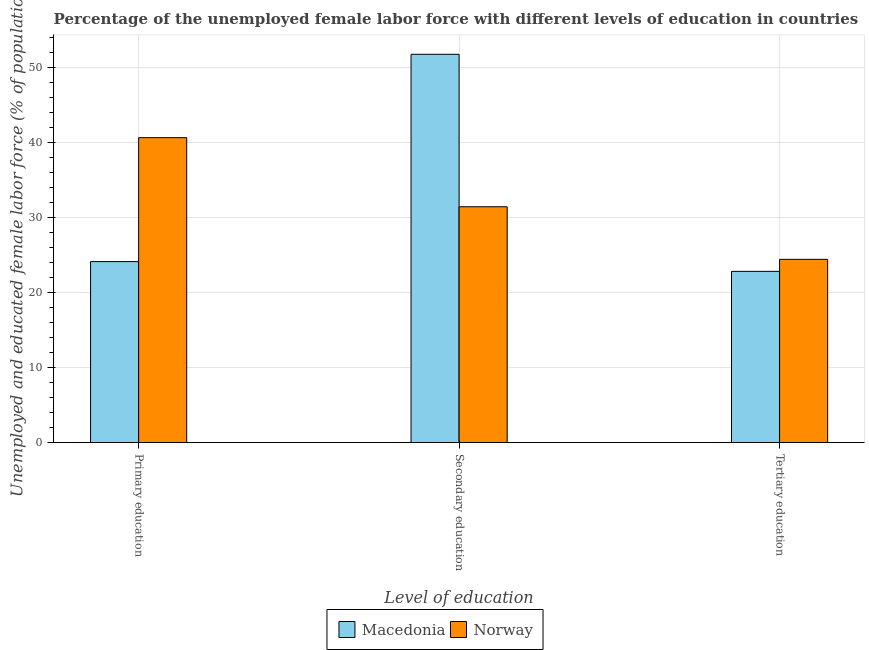How many groups of bars are there?
Your answer should be very brief. 3. Are the number of bars per tick equal to the number of legend labels?
Ensure brevity in your answer.  Yes. How many bars are there on the 3rd tick from the left?
Provide a succinct answer. 2. How many bars are there on the 2nd tick from the right?
Offer a very short reply. 2. What is the label of the 3rd group of bars from the left?
Keep it short and to the point. Tertiary education. What is the percentage of female labor force who received secondary education in Norway?
Your answer should be very brief. 31.4. Across all countries, what is the maximum percentage of female labor force who received primary education?
Your response must be concise. 40.6. Across all countries, what is the minimum percentage of female labor force who received tertiary education?
Keep it short and to the point. 22.8. In which country was the percentage of female labor force who received secondary education minimum?
Your answer should be compact. Norway. What is the total percentage of female labor force who received secondary education in the graph?
Offer a terse response. 83.1. What is the difference between the percentage of female labor force who received tertiary education in Norway and that in Macedonia?
Your answer should be very brief. 1.6. What is the difference between the percentage of female labor force who received tertiary education in Norway and the percentage of female labor force who received primary education in Macedonia?
Offer a terse response. 0.3. What is the average percentage of female labor force who received secondary education per country?
Keep it short and to the point. 41.55. What is the difference between the percentage of female labor force who received primary education and percentage of female labor force who received tertiary education in Norway?
Ensure brevity in your answer.  16.2. In how many countries, is the percentage of female labor force who received tertiary education greater than 24 %?
Provide a succinct answer. 1. What is the ratio of the percentage of female labor force who received tertiary education in Norway to that in Macedonia?
Offer a terse response. 1.07. Is the percentage of female labor force who received primary education in Norway less than that in Macedonia?
Your answer should be very brief. No. Is the difference between the percentage of female labor force who received primary education in Macedonia and Norway greater than the difference between the percentage of female labor force who received secondary education in Macedonia and Norway?
Your answer should be compact. No. What is the difference between the highest and the second highest percentage of female labor force who received tertiary education?
Your answer should be compact. 1.6. What is the difference between the highest and the lowest percentage of female labor force who received primary education?
Your answer should be compact. 16.5. In how many countries, is the percentage of female labor force who received secondary education greater than the average percentage of female labor force who received secondary education taken over all countries?
Your answer should be compact. 1. Is the sum of the percentage of female labor force who received primary education in Norway and Macedonia greater than the maximum percentage of female labor force who received secondary education across all countries?
Offer a terse response. Yes. What does the 1st bar from the right in Secondary education represents?
Give a very brief answer. Norway. How many bars are there?
Offer a very short reply. 6. Are all the bars in the graph horizontal?
Provide a short and direct response. No. How many countries are there in the graph?
Your answer should be very brief. 2. What is the difference between two consecutive major ticks on the Y-axis?
Offer a very short reply. 10. Are the values on the major ticks of Y-axis written in scientific E-notation?
Your answer should be very brief. No. How are the legend labels stacked?
Offer a terse response. Horizontal. What is the title of the graph?
Make the answer very short. Percentage of the unemployed female labor force with different levels of education in countries. Does "Middle East & North Africa (all income levels)" appear as one of the legend labels in the graph?
Offer a very short reply. No. What is the label or title of the X-axis?
Provide a succinct answer. Level of education. What is the label or title of the Y-axis?
Provide a succinct answer. Unemployed and educated female labor force (% of population). What is the Unemployed and educated female labor force (% of population) in Macedonia in Primary education?
Ensure brevity in your answer.  24.1. What is the Unemployed and educated female labor force (% of population) of Norway in Primary education?
Keep it short and to the point. 40.6. What is the Unemployed and educated female labor force (% of population) of Macedonia in Secondary education?
Offer a very short reply. 51.7. What is the Unemployed and educated female labor force (% of population) in Norway in Secondary education?
Your answer should be compact. 31.4. What is the Unemployed and educated female labor force (% of population) of Macedonia in Tertiary education?
Ensure brevity in your answer.  22.8. What is the Unemployed and educated female labor force (% of population) of Norway in Tertiary education?
Your response must be concise. 24.4. Across all Level of education, what is the maximum Unemployed and educated female labor force (% of population) in Macedonia?
Ensure brevity in your answer.  51.7. Across all Level of education, what is the maximum Unemployed and educated female labor force (% of population) in Norway?
Give a very brief answer. 40.6. Across all Level of education, what is the minimum Unemployed and educated female labor force (% of population) in Macedonia?
Make the answer very short. 22.8. Across all Level of education, what is the minimum Unemployed and educated female labor force (% of population) of Norway?
Make the answer very short. 24.4. What is the total Unemployed and educated female labor force (% of population) in Macedonia in the graph?
Keep it short and to the point. 98.6. What is the total Unemployed and educated female labor force (% of population) in Norway in the graph?
Give a very brief answer. 96.4. What is the difference between the Unemployed and educated female labor force (% of population) in Macedonia in Primary education and that in Secondary education?
Your answer should be very brief. -27.6. What is the difference between the Unemployed and educated female labor force (% of population) in Norway in Primary education and that in Tertiary education?
Your answer should be compact. 16.2. What is the difference between the Unemployed and educated female labor force (% of population) in Macedonia in Secondary education and that in Tertiary education?
Give a very brief answer. 28.9. What is the difference between the Unemployed and educated female labor force (% of population) in Macedonia in Primary education and the Unemployed and educated female labor force (% of population) in Norway in Secondary education?
Keep it short and to the point. -7.3. What is the difference between the Unemployed and educated female labor force (% of population) of Macedonia in Secondary education and the Unemployed and educated female labor force (% of population) of Norway in Tertiary education?
Ensure brevity in your answer.  27.3. What is the average Unemployed and educated female labor force (% of population) of Macedonia per Level of education?
Your response must be concise. 32.87. What is the average Unemployed and educated female labor force (% of population) in Norway per Level of education?
Give a very brief answer. 32.13. What is the difference between the Unemployed and educated female labor force (% of population) in Macedonia and Unemployed and educated female labor force (% of population) in Norway in Primary education?
Make the answer very short. -16.5. What is the difference between the Unemployed and educated female labor force (% of population) in Macedonia and Unemployed and educated female labor force (% of population) in Norway in Secondary education?
Provide a short and direct response. 20.3. What is the ratio of the Unemployed and educated female labor force (% of population) in Macedonia in Primary education to that in Secondary education?
Keep it short and to the point. 0.47. What is the ratio of the Unemployed and educated female labor force (% of population) of Norway in Primary education to that in Secondary education?
Provide a succinct answer. 1.29. What is the ratio of the Unemployed and educated female labor force (% of population) in Macedonia in Primary education to that in Tertiary education?
Your answer should be compact. 1.06. What is the ratio of the Unemployed and educated female labor force (% of population) of Norway in Primary education to that in Tertiary education?
Offer a terse response. 1.66. What is the ratio of the Unemployed and educated female labor force (% of population) of Macedonia in Secondary education to that in Tertiary education?
Provide a short and direct response. 2.27. What is the ratio of the Unemployed and educated female labor force (% of population) in Norway in Secondary education to that in Tertiary education?
Provide a short and direct response. 1.29. What is the difference between the highest and the second highest Unemployed and educated female labor force (% of population) in Macedonia?
Provide a succinct answer. 27.6. What is the difference between the highest and the second highest Unemployed and educated female labor force (% of population) in Norway?
Offer a very short reply. 9.2. What is the difference between the highest and the lowest Unemployed and educated female labor force (% of population) of Macedonia?
Provide a short and direct response. 28.9. What is the difference between the highest and the lowest Unemployed and educated female labor force (% of population) of Norway?
Your answer should be very brief. 16.2. 